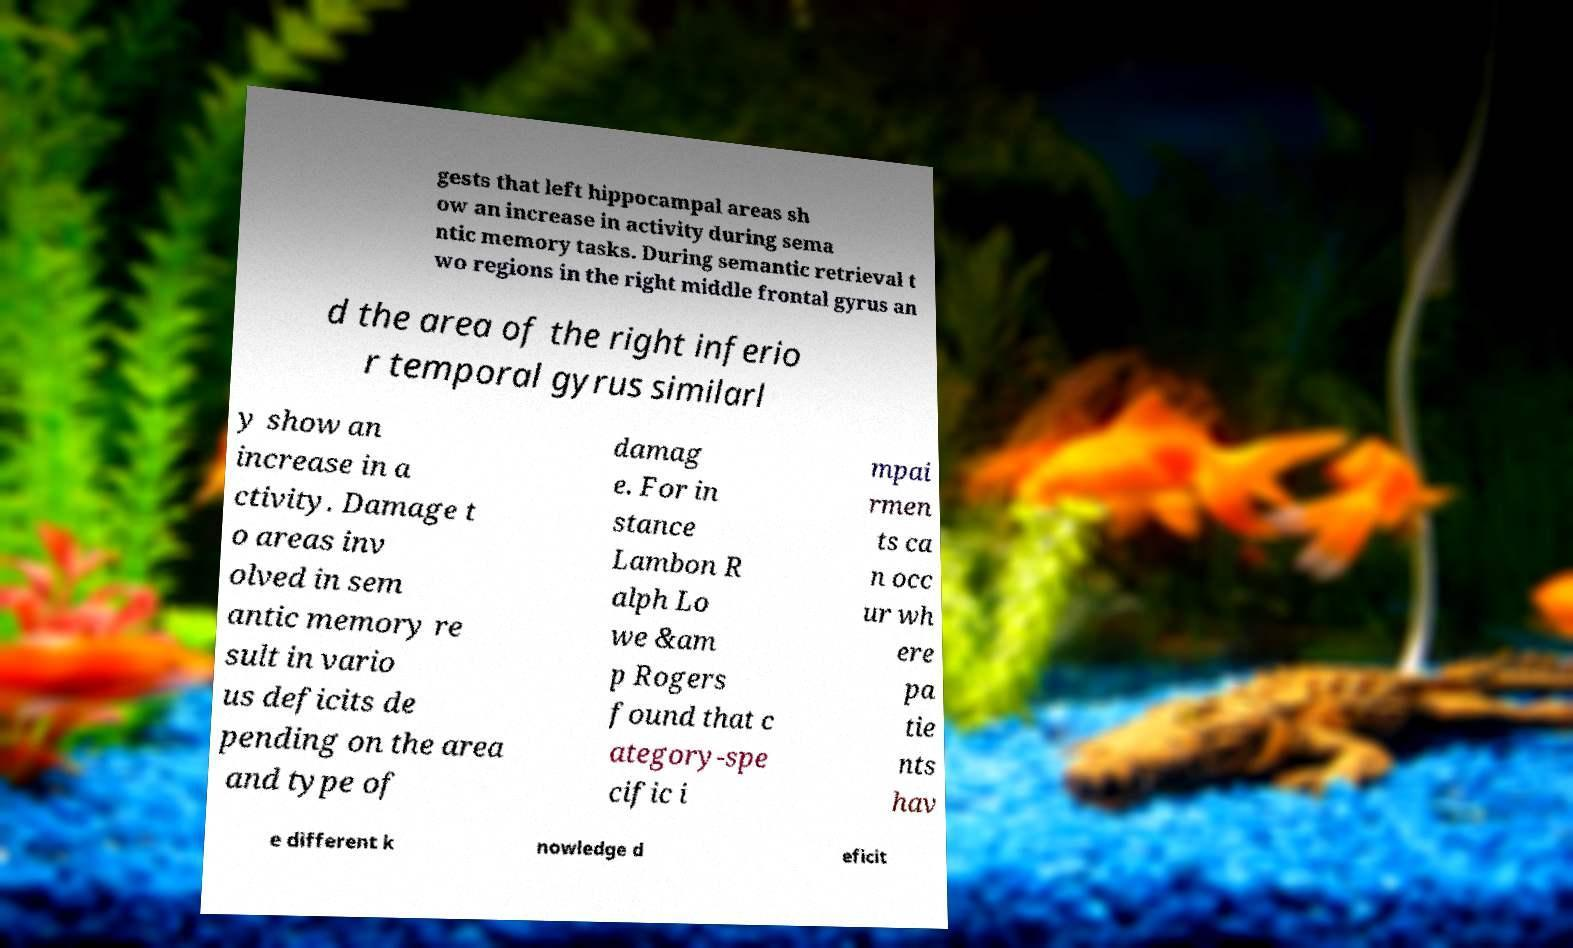What messages or text are displayed in this image? I need them in a readable, typed format. gests that left hippocampal areas sh ow an increase in activity during sema ntic memory tasks. During semantic retrieval t wo regions in the right middle frontal gyrus an d the area of the right inferio r temporal gyrus similarl y show an increase in a ctivity. Damage t o areas inv olved in sem antic memory re sult in vario us deficits de pending on the area and type of damag e. For in stance Lambon R alph Lo we &am p Rogers found that c ategory-spe cific i mpai rmen ts ca n occ ur wh ere pa tie nts hav e different k nowledge d eficit 